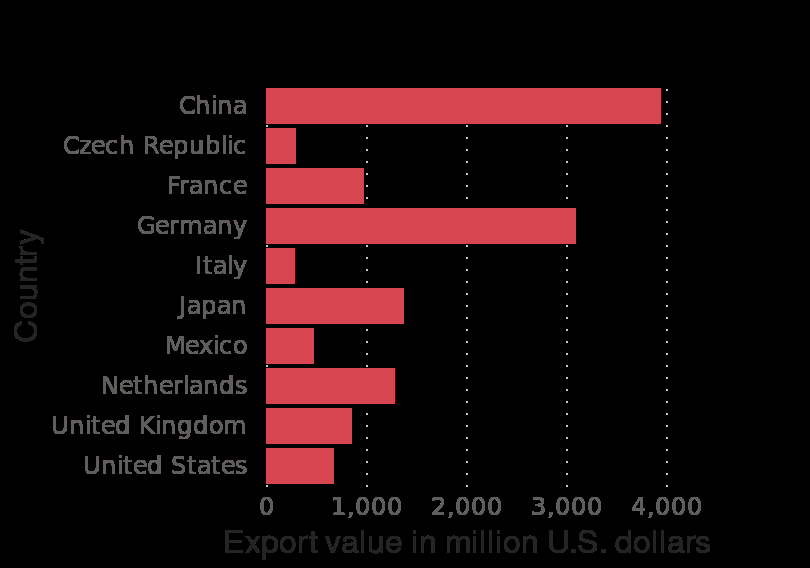<image>
What does the bar diagram show? The bar diagram shows the leading exporting countries of office supplies worldwide in 2018, based on their export values in million U.S. dollars. Which countries were the biggest exporters of office supplies worldwide in 2018? China and Germany were the biggest exporters of office supplies worldwide in 2018. 